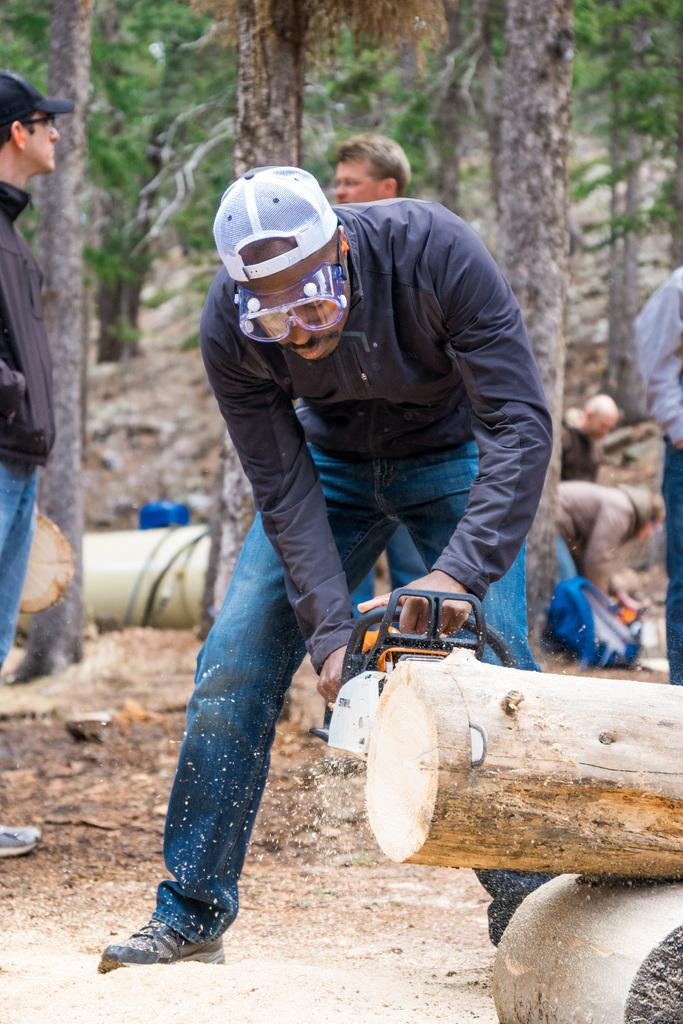What are the people in the image doing? The people in the image are standing on the ground. What is the man holding in his hands? The man is holding an object in his hands. What can be seen in the distance behind the people? There are trees visible in the background of the image. Can you describe any other elements in the background of the image? There are other unspecified elements in the background of the image. What type of gun is being used on the object in the image? There is no gun present in the image; the man is holding an unspecified object. 